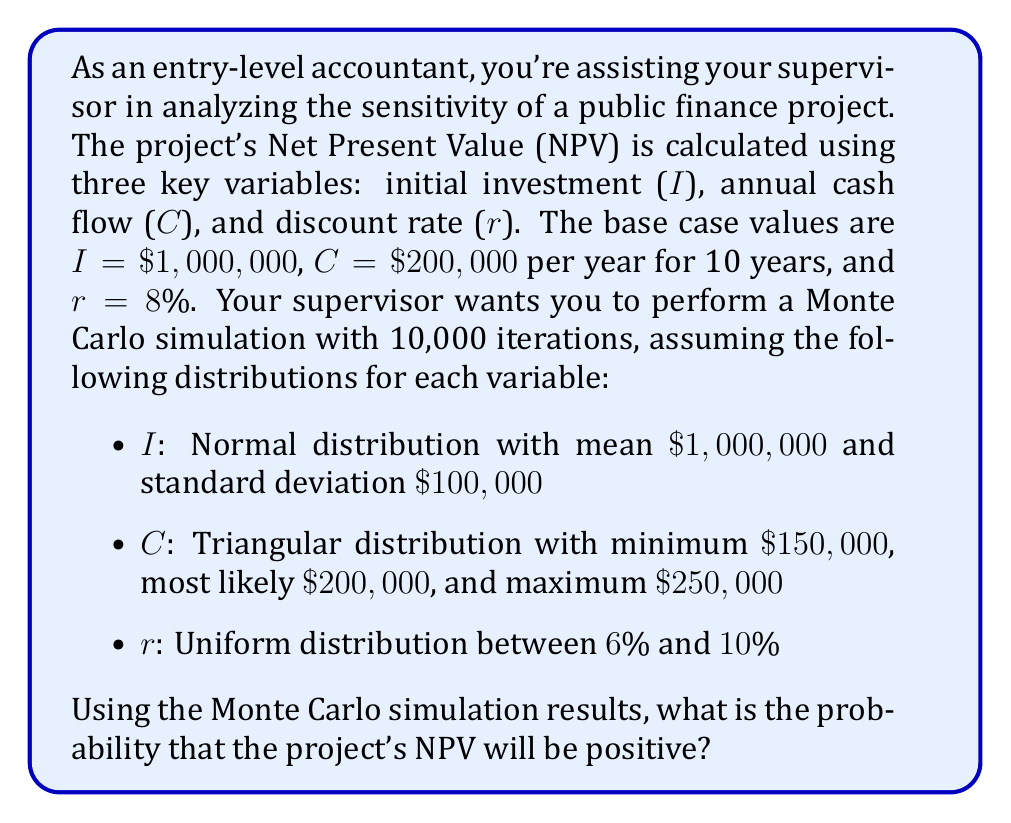Give your solution to this math problem. To solve this problem, we need to follow these steps:

1) First, let's recall the NPV formula:

   $$ NPV = -I + \sum_{t=1}^{n} \frac{C_t}{(1+r)^t} $$

   Where I is the initial investment, $C_t$ is the cash flow at time t, r is the discount rate, and n is the number of periods.

2) In this case, we have constant annual cash flows for 10 years, so we can simplify this to:

   $$ NPV = -I + C \cdot \frac{1-(1+r)^{-10}}{r} $$

3) Now, we need to set up the Monte Carlo simulation. For each iteration:
   - Generate a random value for I from N($1,000,000, 100,000$)
   - Generate a random value for C from Triangular($150,000, 200,000, 250,000$)
   - Generate a random value for r from Uniform(0.06, 0.10)
   - Calculate the NPV using these values
   - Check if the NPV is positive

4) After running 10,000 iterations, count how many times the NPV was positive.

5) The probability of a positive NPV is then:

   $$ P(NPV > 0) = \frac{\text{Number of positive NPV outcomes}}{10,000} $$

While we can't perform the actual simulation here, we can estimate the result based on the given information:

- The initial investment is likely to be close to $1,000,000 on average.
- The cash flow is likely to be around $200,000 on average, possibly slightly higher due to the triangular distribution.
- The discount rate will average around 8%.

These values are close to the base case, which would yield a slightly positive NPV. However, the variability in all three parameters introduces significant uncertainty.

Given this, we might expect the probability of a positive NPV to be somewhat above 50%, but not overwhelmingly so.
Answer: The exact probability would require running the actual Monte Carlo simulation, but based on the given parameters, a reasonable estimate for the probability of a positive NPV would be in the range of 55% to 65%. 